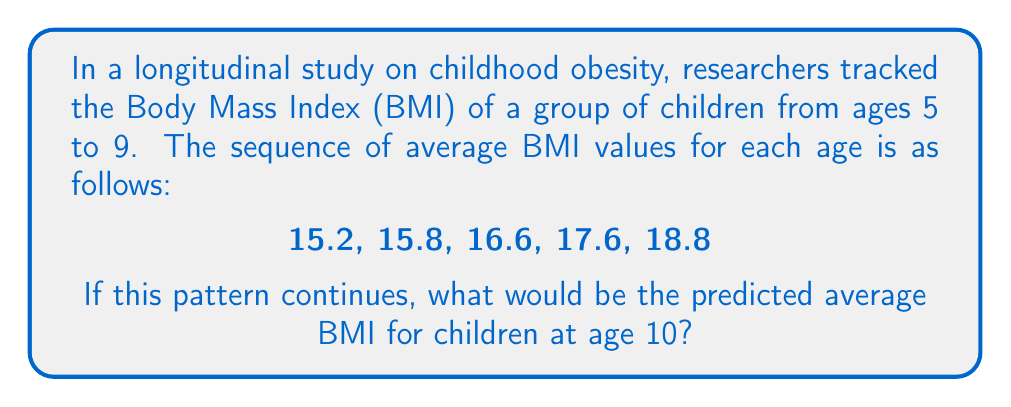What is the answer to this math problem? To solve this problem, we need to identify the pattern in the given sequence of BMI values:

1. Calculate the differences between consecutive terms:
   15.8 - 15.2 = 0.6
   16.6 - 15.8 = 0.8
   17.6 - 16.6 = 1.0
   18.8 - 17.6 = 1.2

2. Observe that the differences are increasing by 0.2 each time:
   0.6 → 0.8 → 1.0 → 1.2

3. The pattern suggests that the next difference will be 1.4.

4. To find the predicted BMI for age 10, add this difference to the last given term:
   $18.8 + 1.4 = 20.2$

Therefore, the predicted average BMI for children at age 10 would be 20.2.

This pattern can be represented by the quadratic sequence:

$BMI_n = 15.2 + 0.4(n-1) + 0.1(n-1)^2$

Where $n$ is the number of years after age 5. For age 10, $n = 5$:

$BMI_5 = 15.2 + 0.4(4) + 0.1(4)^2 = 15.2 + 1.6 + 1.6 = 20.2$

This quadratic growth pattern aligns with the accelerating increase in BMI often observed during childhood, which is relevant to the researcher's focus on early life experiences and health outcomes.
Answer: 20.2 